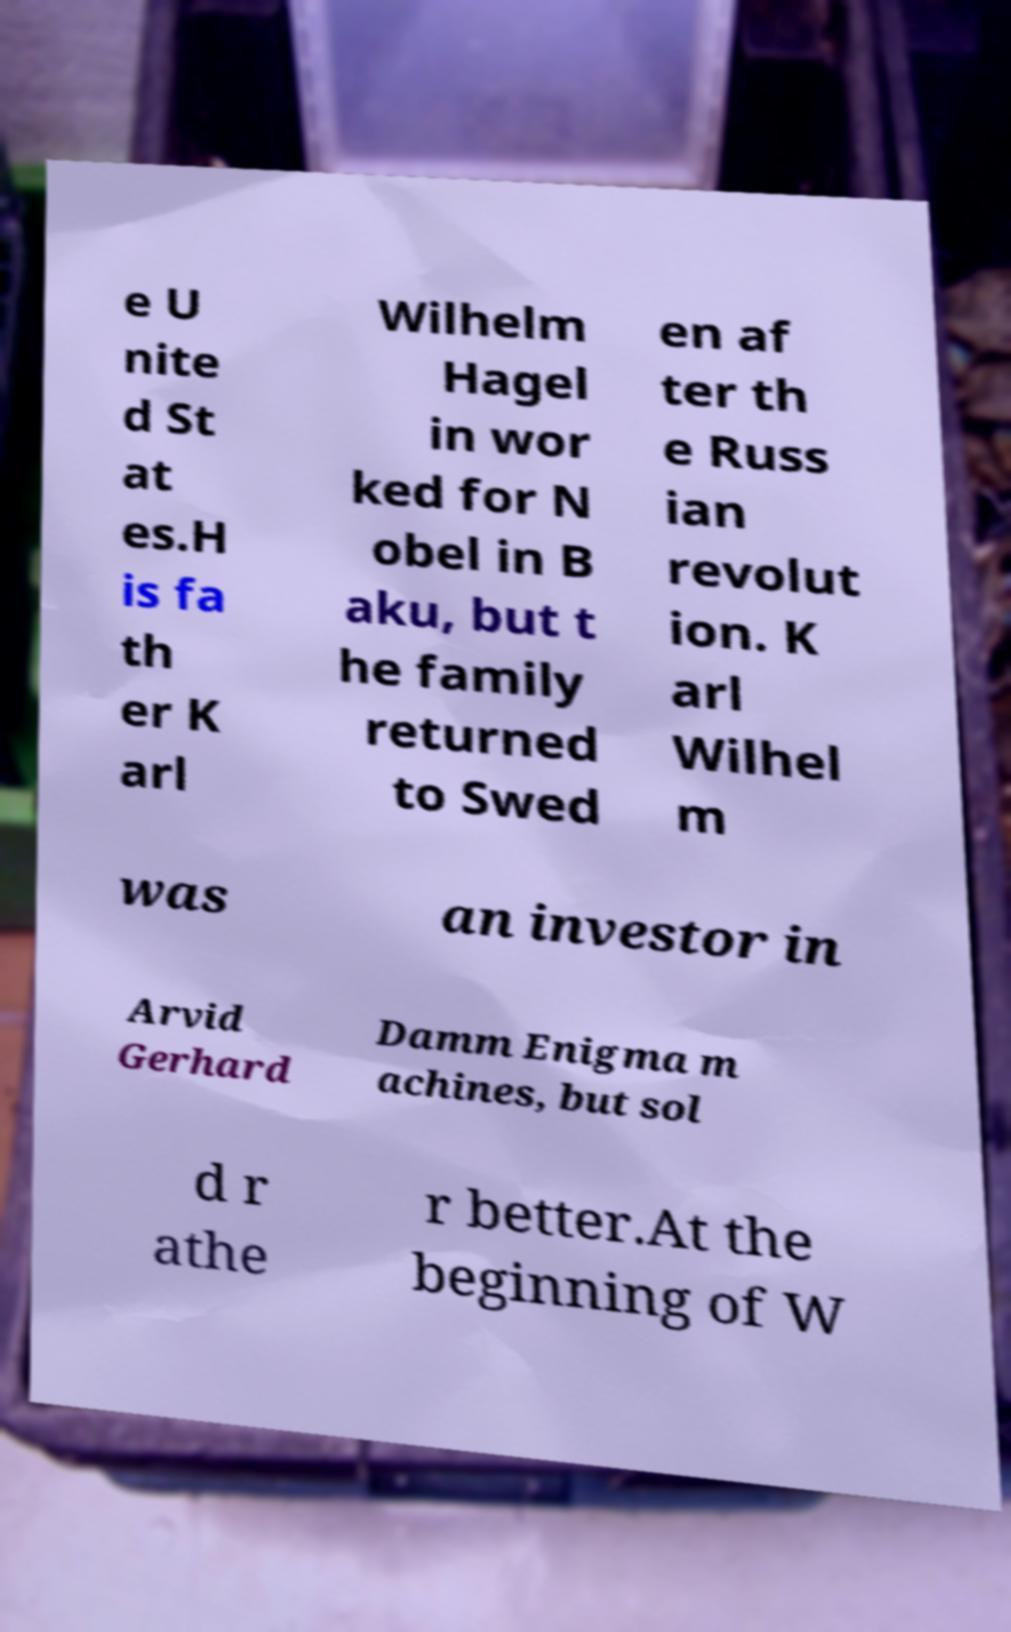I need the written content from this picture converted into text. Can you do that? e U nite d St at es.H is fa th er K arl Wilhelm Hagel in wor ked for N obel in B aku, but t he family returned to Swed en af ter th e Russ ian revolut ion. K arl Wilhel m was an investor in Arvid Gerhard Damm Enigma m achines, but sol d r athe r better.At the beginning of W 